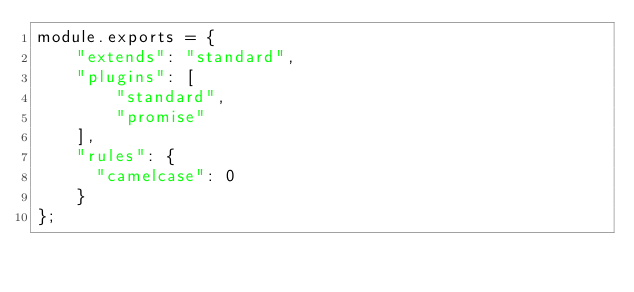Convert code to text. <code><loc_0><loc_0><loc_500><loc_500><_JavaScript_>module.exports = {
    "extends": "standard",
    "plugins": [
        "standard",
        "promise"
    ],
    "rules": {
      "camelcase": 0
    }
};
</code> 